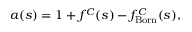<formula> <loc_0><loc_0><loc_500><loc_500>a ( s ) = 1 + f ^ { C } ( s ) - f _ { B o r n } ^ { C } ( s ) ,</formula> 